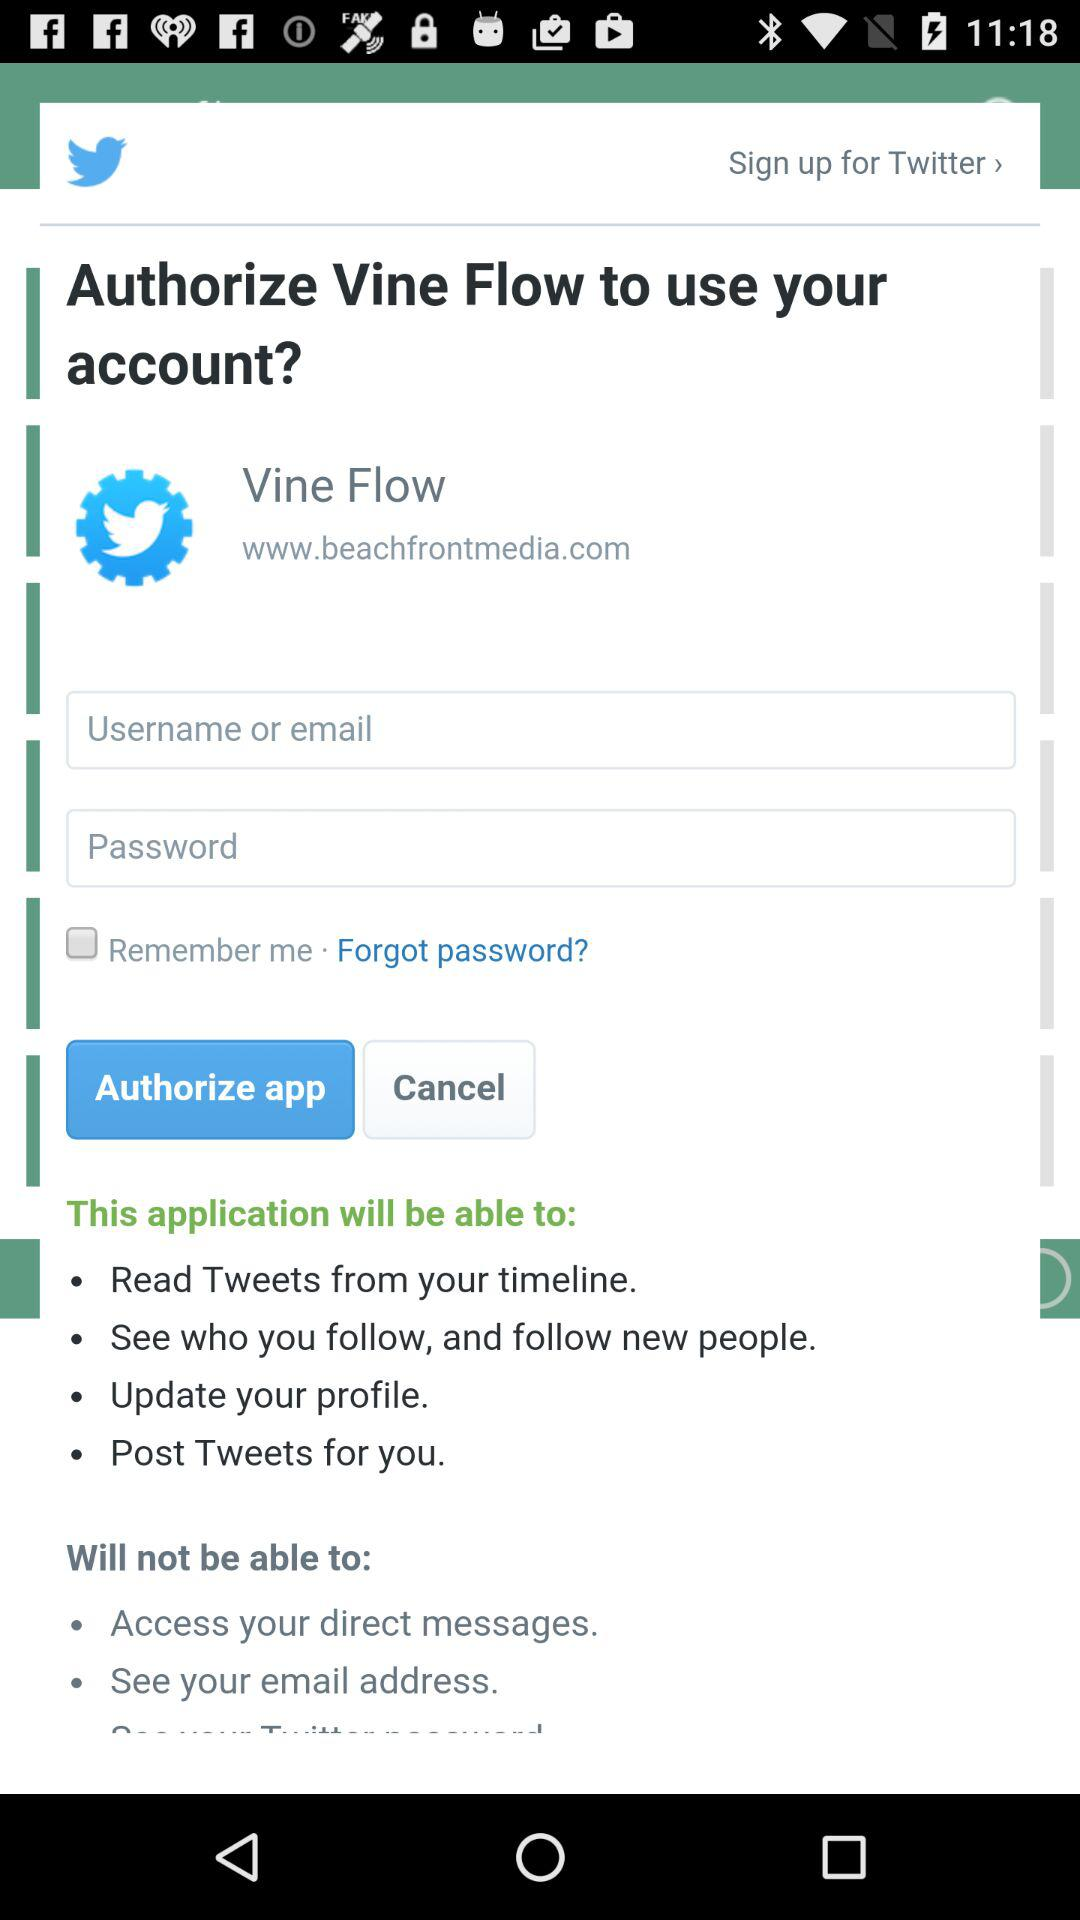Is "Remember me" checked or not?
Answer the question using a single word or phrase. It is "unchecked". 